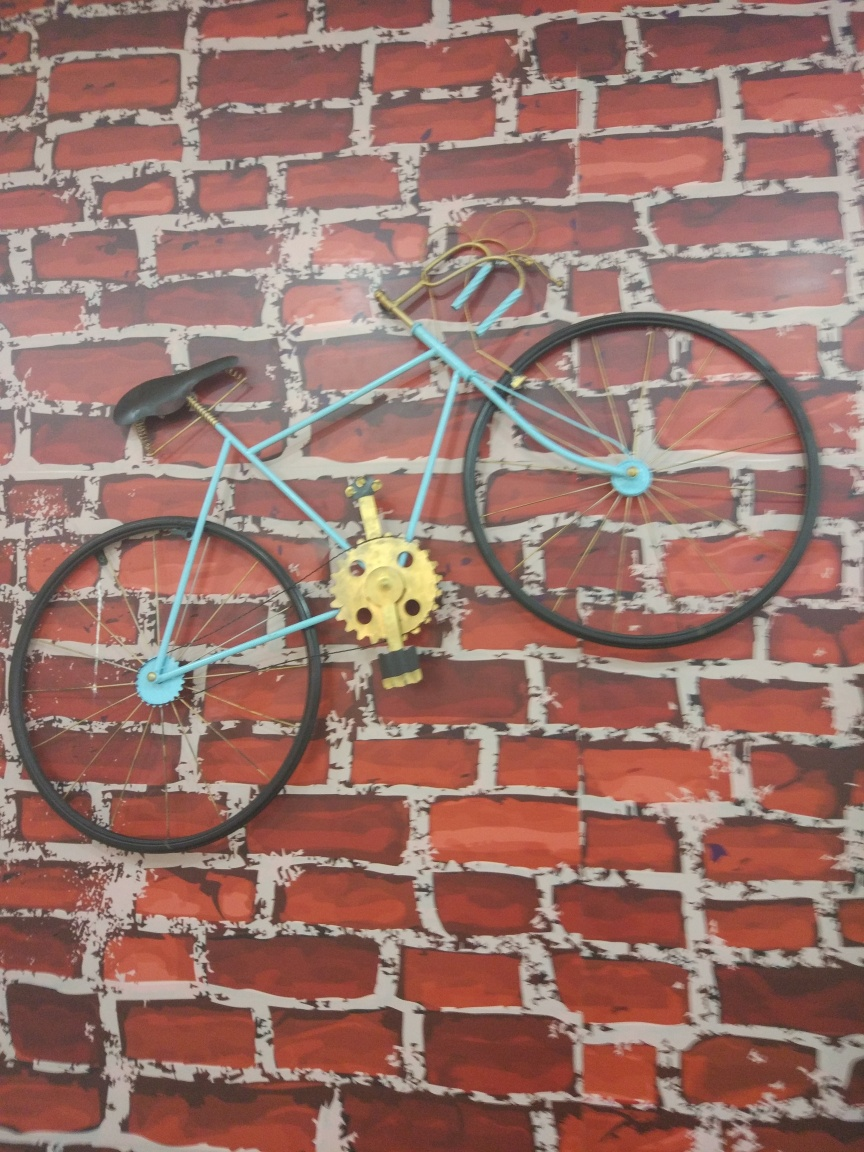Could this bicycle be functional or is it purely a decorative item? This bicycle appears to be primarily a decorative item. It's mounted on a wall, and its positioning does not seem practical for riding. The pedals are detached and resting on the bicycle's lower bar, and there are decorative elements attached, such as the golden object placed in the center of the frame. While it retains the overall shape of a functional bicycle, its current state suggests it's not intended for riding. 